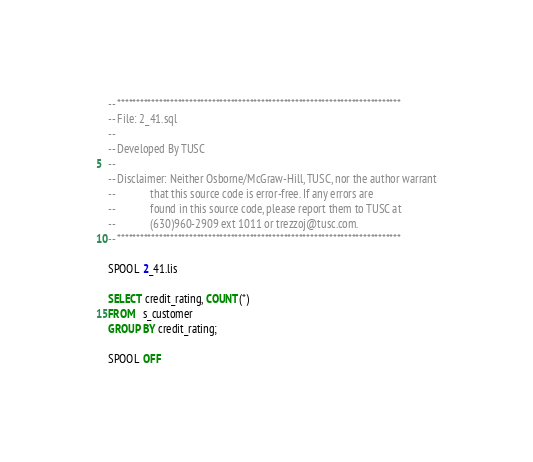<code> <loc_0><loc_0><loc_500><loc_500><_SQL_>-- ***************************************************************************
-- File: 2_41.sql
--
-- Developed By TUSC
--
-- Disclaimer: Neither Osborne/McGraw-Hill, TUSC, nor the author warrant
--             that this source code is error-free. If any errors are
--             found in this source code, please report them to TUSC at
--             (630)960-2909 ext 1011 or trezzoj@tusc.com.
-- ***************************************************************************

SPOOL 2_41.lis

SELECT credit_rating, COUNT(*)
FROM   s_customer
GROUP BY credit_rating;

SPOOL OFF
</code> 